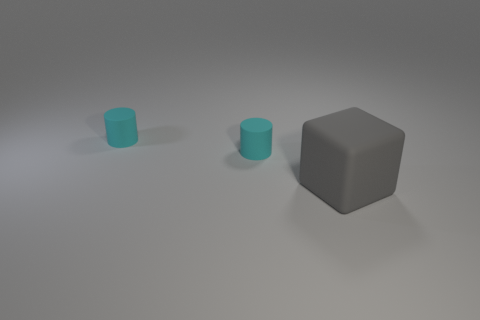What is the block made of?
Your response must be concise. Rubber. Are there any gray cubes to the right of the matte block?
Make the answer very short. No. How many other objects are the same material as the block?
Ensure brevity in your answer.  2. There is a large matte block; how many cylinders are to the left of it?
Your answer should be compact. 2. What number of cylinders are either big rubber objects or cyan objects?
Your answer should be compact. 2. How many things are either rubber objects left of the gray thing or rubber blocks?
Provide a succinct answer. 3. Is there anything else that is the same size as the rubber block?
Provide a short and direct response. No. What number of objects are either objects that are on the left side of the gray object or things behind the gray thing?
Make the answer very short. 2. Are there any other things that have the same material as the block?
Your answer should be very brief. Yes. Are there fewer large gray matte objects that are to the left of the large cube than rubber cubes?
Provide a succinct answer. Yes. 